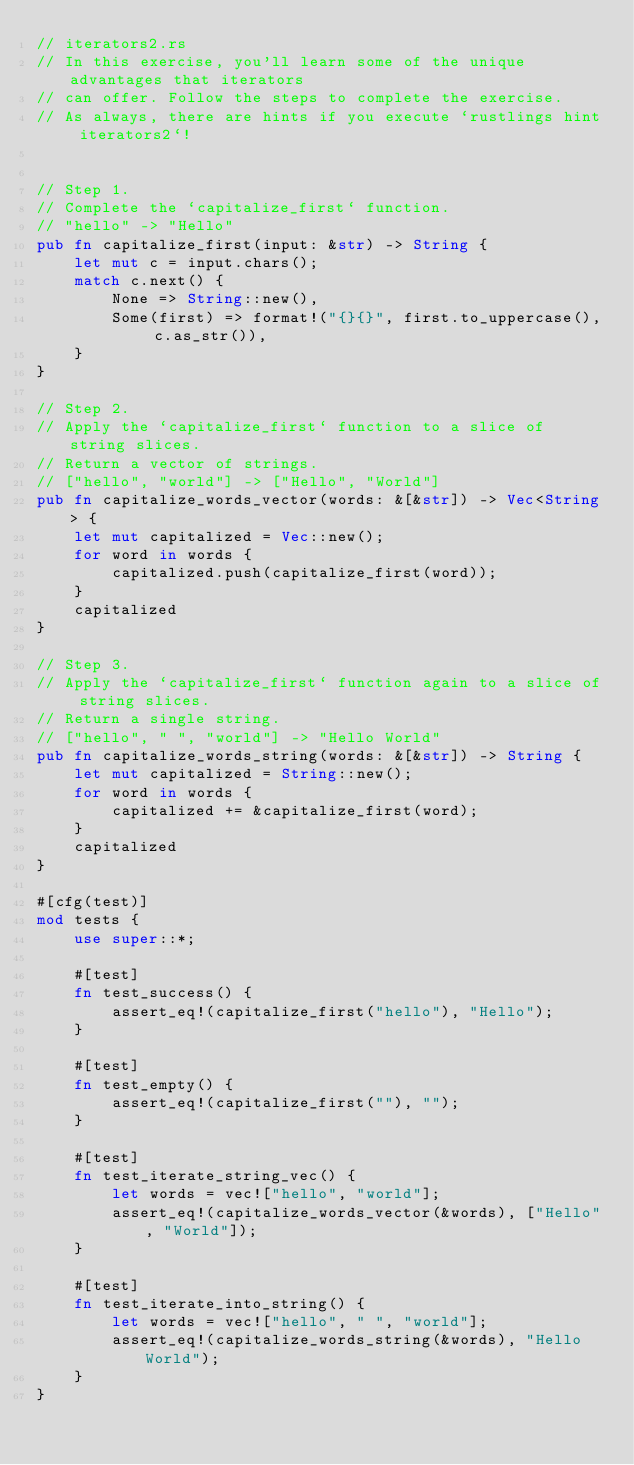<code> <loc_0><loc_0><loc_500><loc_500><_Rust_>// iterators2.rs
// In this exercise, you'll learn some of the unique advantages that iterators
// can offer. Follow the steps to complete the exercise.
// As always, there are hints if you execute `rustlings hint iterators2`!


// Step 1.
// Complete the `capitalize_first` function.
// "hello" -> "Hello"
pub fn capitalize_first(input: &str) -> String {
    let mut c = input.chars();
    match c.next() {
        None => String::new(),
        Some(first) => format!("{}{}", first.to_uppercase(), c.as_str()),
    }
}

// Step 2.
// Apply the `capitalize_first` function to a slice of string slices.
// Return a vector of strings.
// ["hello", "world"] -> ["Hello", "World"]
pub fn capitalize_words_vector(words: &[&str]) -> Vec<String> {
    let mut capitalized = Vec::new();
    for word in words {
        capitalized.push(capitalize_first(word));
    }
    capitalized
}

// Step 3.
// Apply the `capitalize_first` function again to a slice of string slices.
// Return a single string.
// ["hello", " ", "world"] -> "Hello World"
pub fn capitalize_words_string(words: &[&str]) -> String {
    let mut capitalized = String::new();
    for word in words {
        capitalized += &capitalize_first(word);
    }
    capitalized
}

#[cfg(test)]
mod tests {
    use super::*;

    #[test]
    fn test_success() {
        assert_eq!(capitalize_first("hello"), "Hello");
    }

    #[test]
    fn test_empty() {
        assert_eq!(capitalize_first(""), "");
    }

    #[test]
    fn test_iterate_string_vec() {
        let words = vec!["hello", "world"];
        assert_eq!(capitalize_words_vector(&words), ["Hello", "World"]);
    }

    #[test]
    fn test_iterate_into_string() {
        let words = vec!["hello", " ", "world"];
        assert_eq!(capitalize_words_string(&words), "Hello World");
    }
}
</code> 